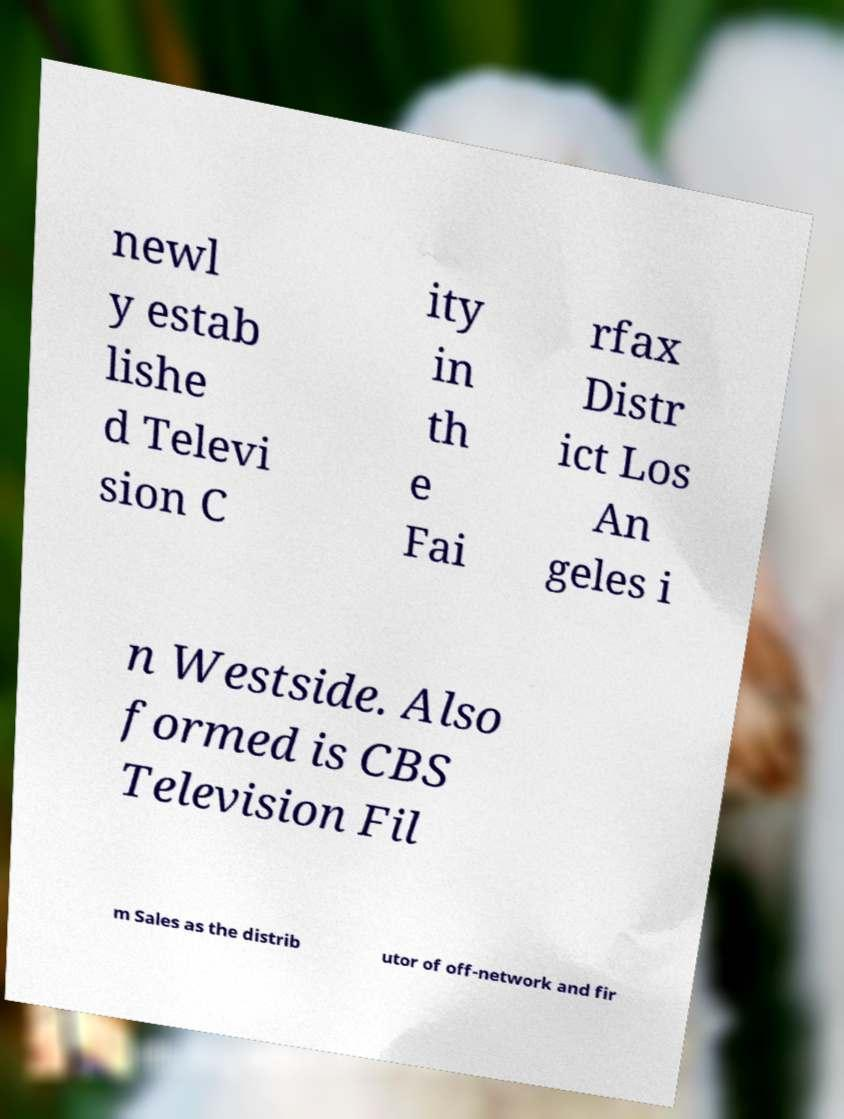Can you read and provide the text displayed in the image?This photo seems to have some interesting text. Can you extract and type it out for me? newl y estab lishe d Televi sion C ity in th e Fai rfax Distr ict Los An geles i n Westside. Also formed is CBS Television Fil m Sales as the distrib utor of off-network and fir 